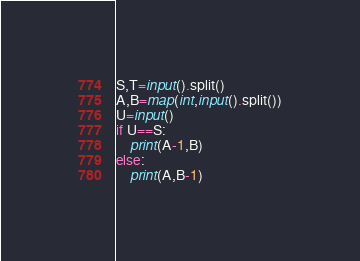<code> <loc_0><loc_0><loc_500><loc_500><_Python_>S,T=input().split()
A,B=map(int,input().split())
U=input()
if U==S:
	print(A-1,B)
else:
	print(A,B-1)</code> 